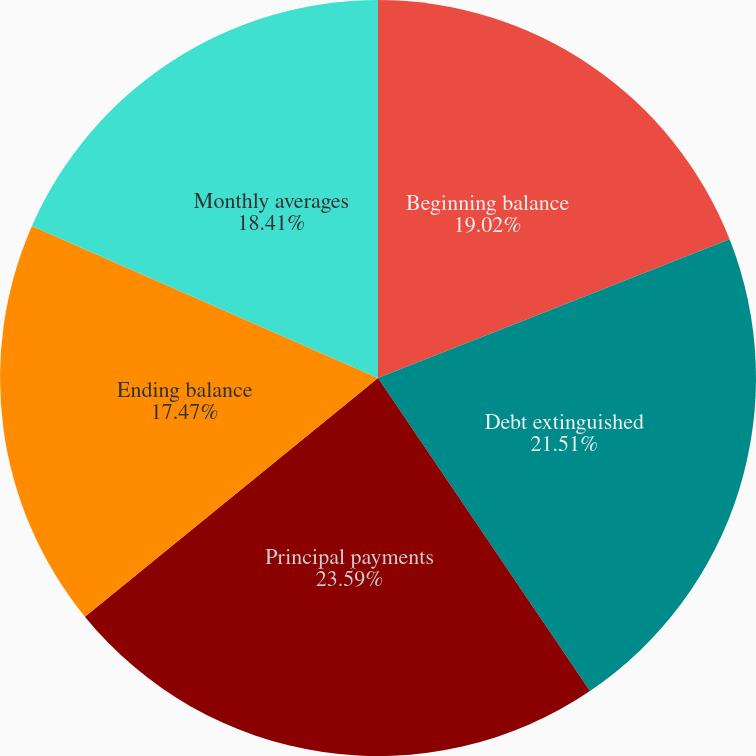<chart> <loc_0><loc_0><loc_500><loc_500><pie_chart><fcel>Beginning balance<fcel>Debt extinguished<fcel>Principal payments<fcel>Ending balance<fcel>Monthly averages<nl><fcel>19.02%<fcel>21.51%<fcel>23.6%<fcel>17.47%<fcel>18.41%<nl></chart> 